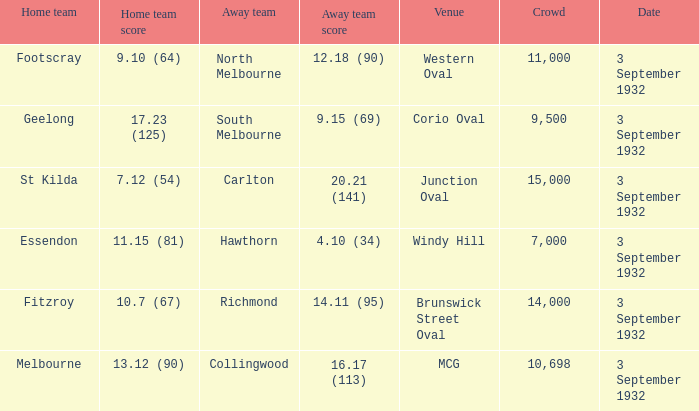What is the name of the Venue for the team that has an Away team score of 14.11 (95)? Brunswick Street Oval. 